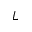Convert formula to latex. <formula><loc_0><loc_0><loc_500><loc_500>L</formula> 